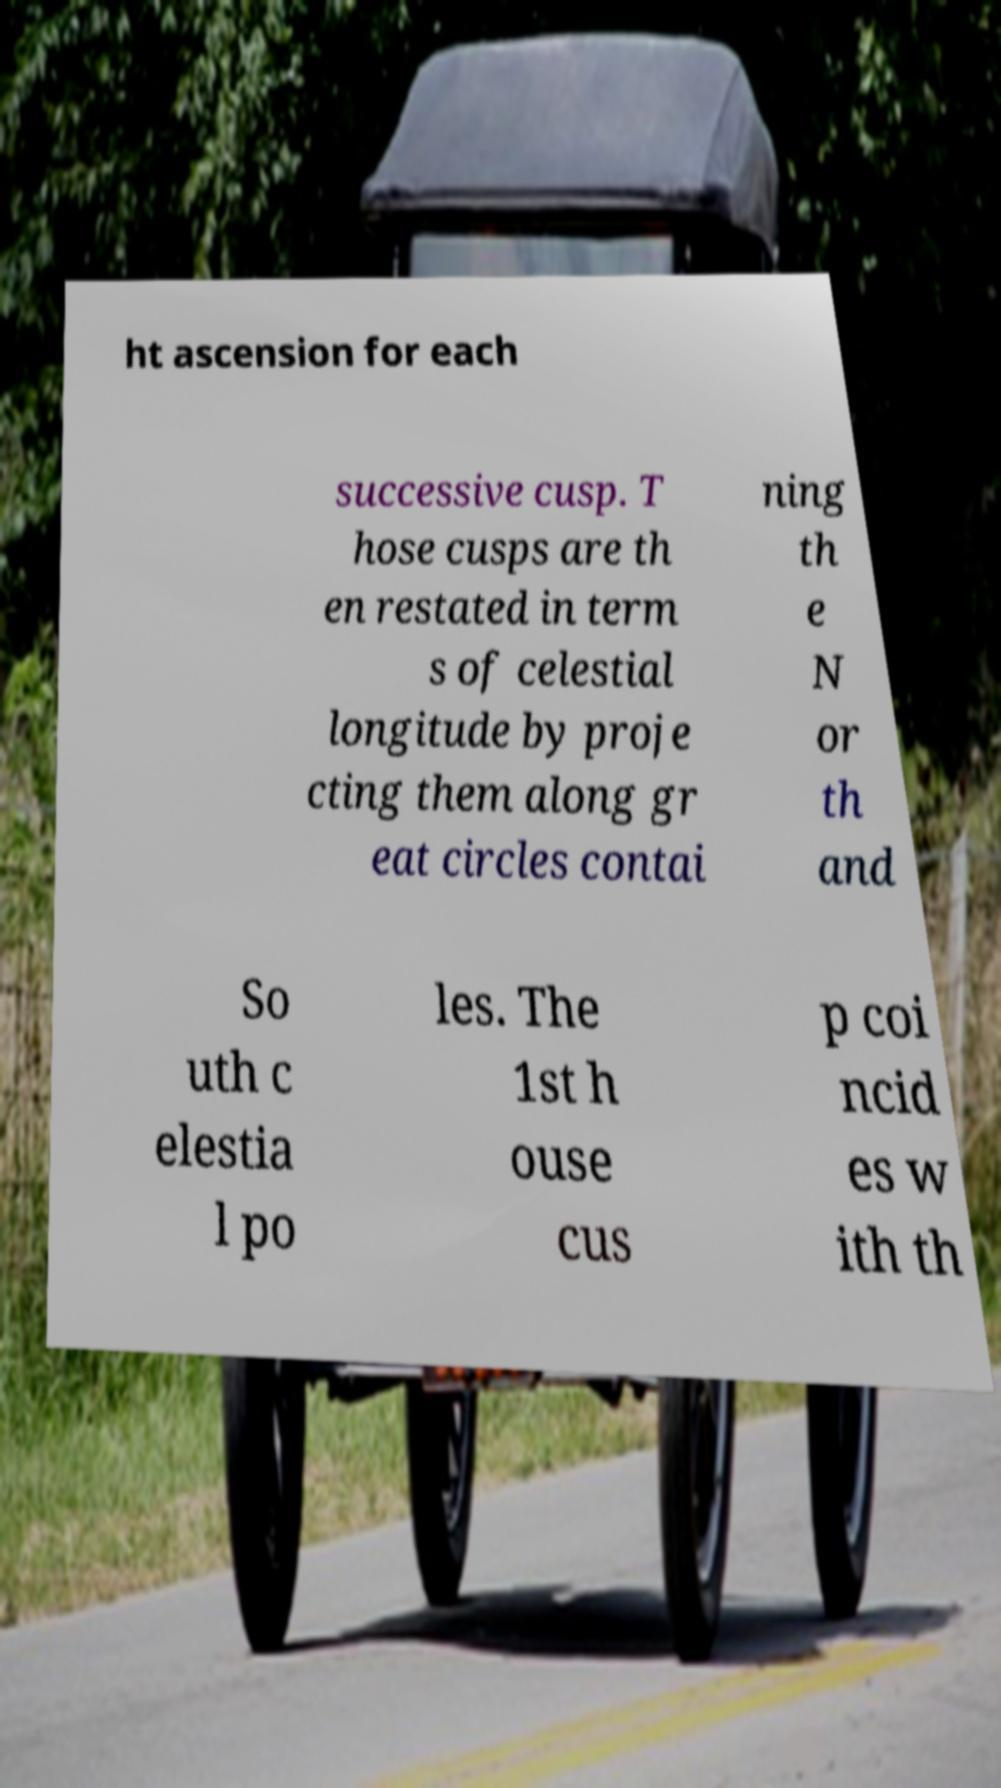I need the written content from this picture converted into text. Can you do that? ht ascension for each successive cusp. T hose cusps are th en restated in term s of celestial longitude by proje cting them along gr eat circles contai ning th e N or th and So uth c elestia l po les. The 1st h ouse cus p coi ncid es w ith th 